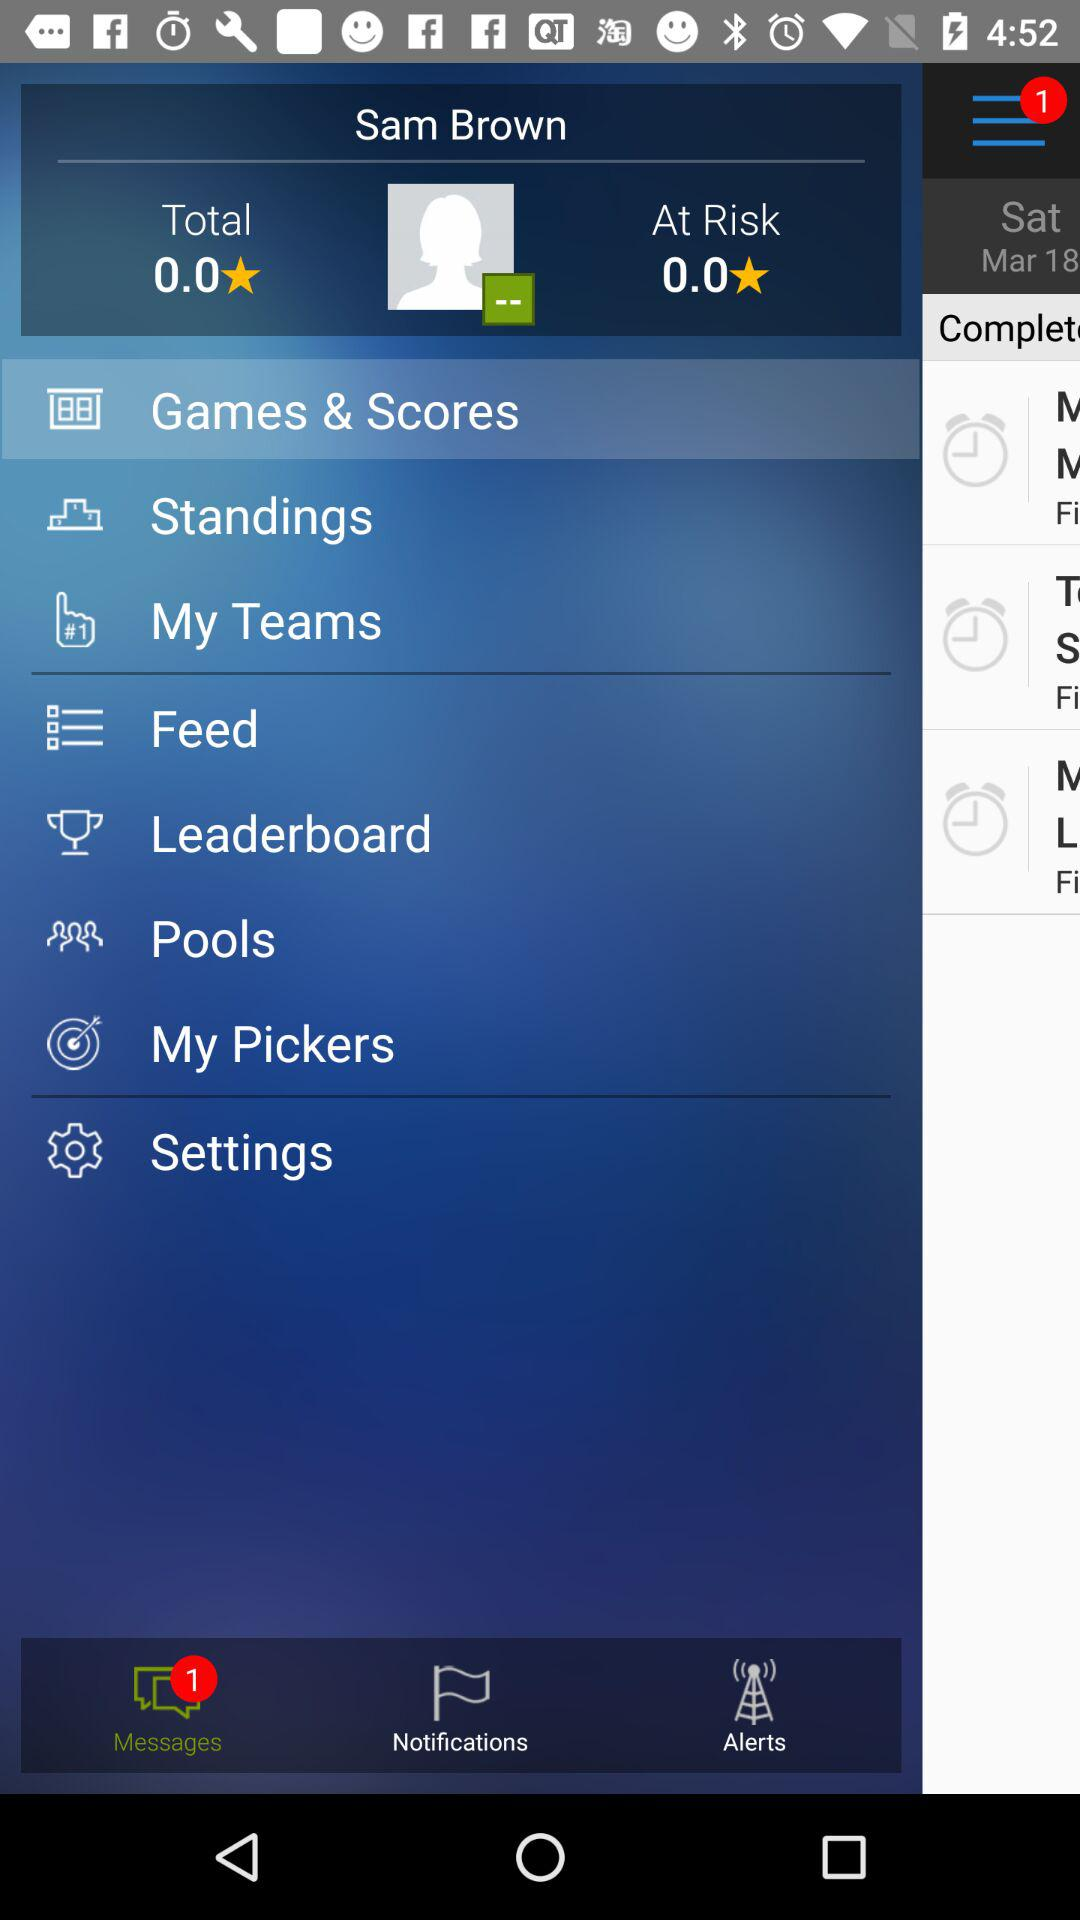What is the name of the user? The name of the user is Sam Brown. 